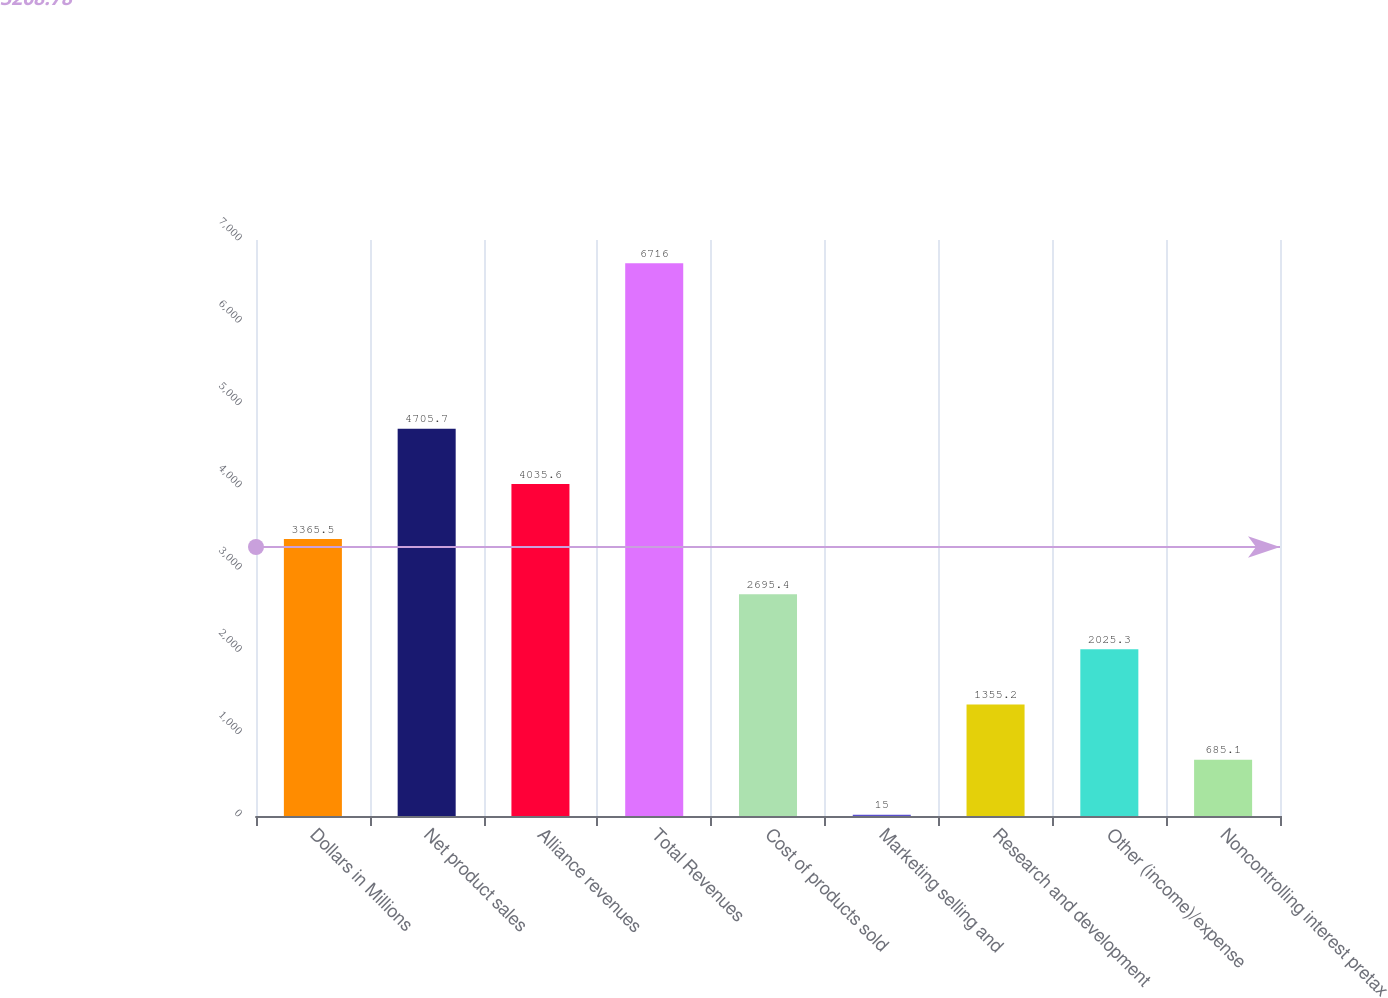Convert chart. <chart><loc_0><loc_0><loc_500><loc_500><bar_chart><fcel>Dollars in Millions<fcel>Net product sales<fcel>Alliance revenues<fcel>Total Revenues<fcel>Cost of products sold<fcel>Marketing selling and<fcel>Research and development<fcel>Other (income)/expense<fcel>Noncontrolling interest pretax<nl><fcel>3365.5<fcel>4705.7<fcel>4035.6<fcel>6716<fcel>2695.4<fcel>15<fcel>1355.2<fcel>2025.3<fcel>685.1<nl></chart> 